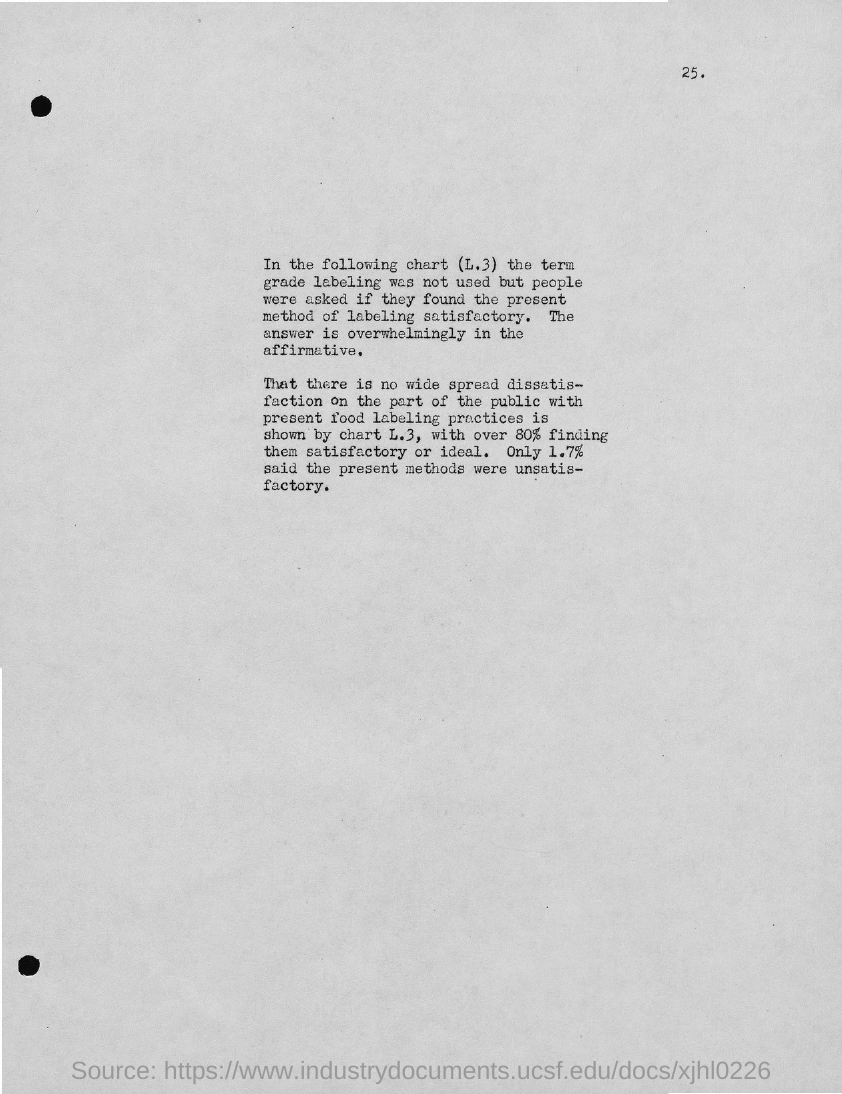What is the page number?
Make the answer very short. 25. 